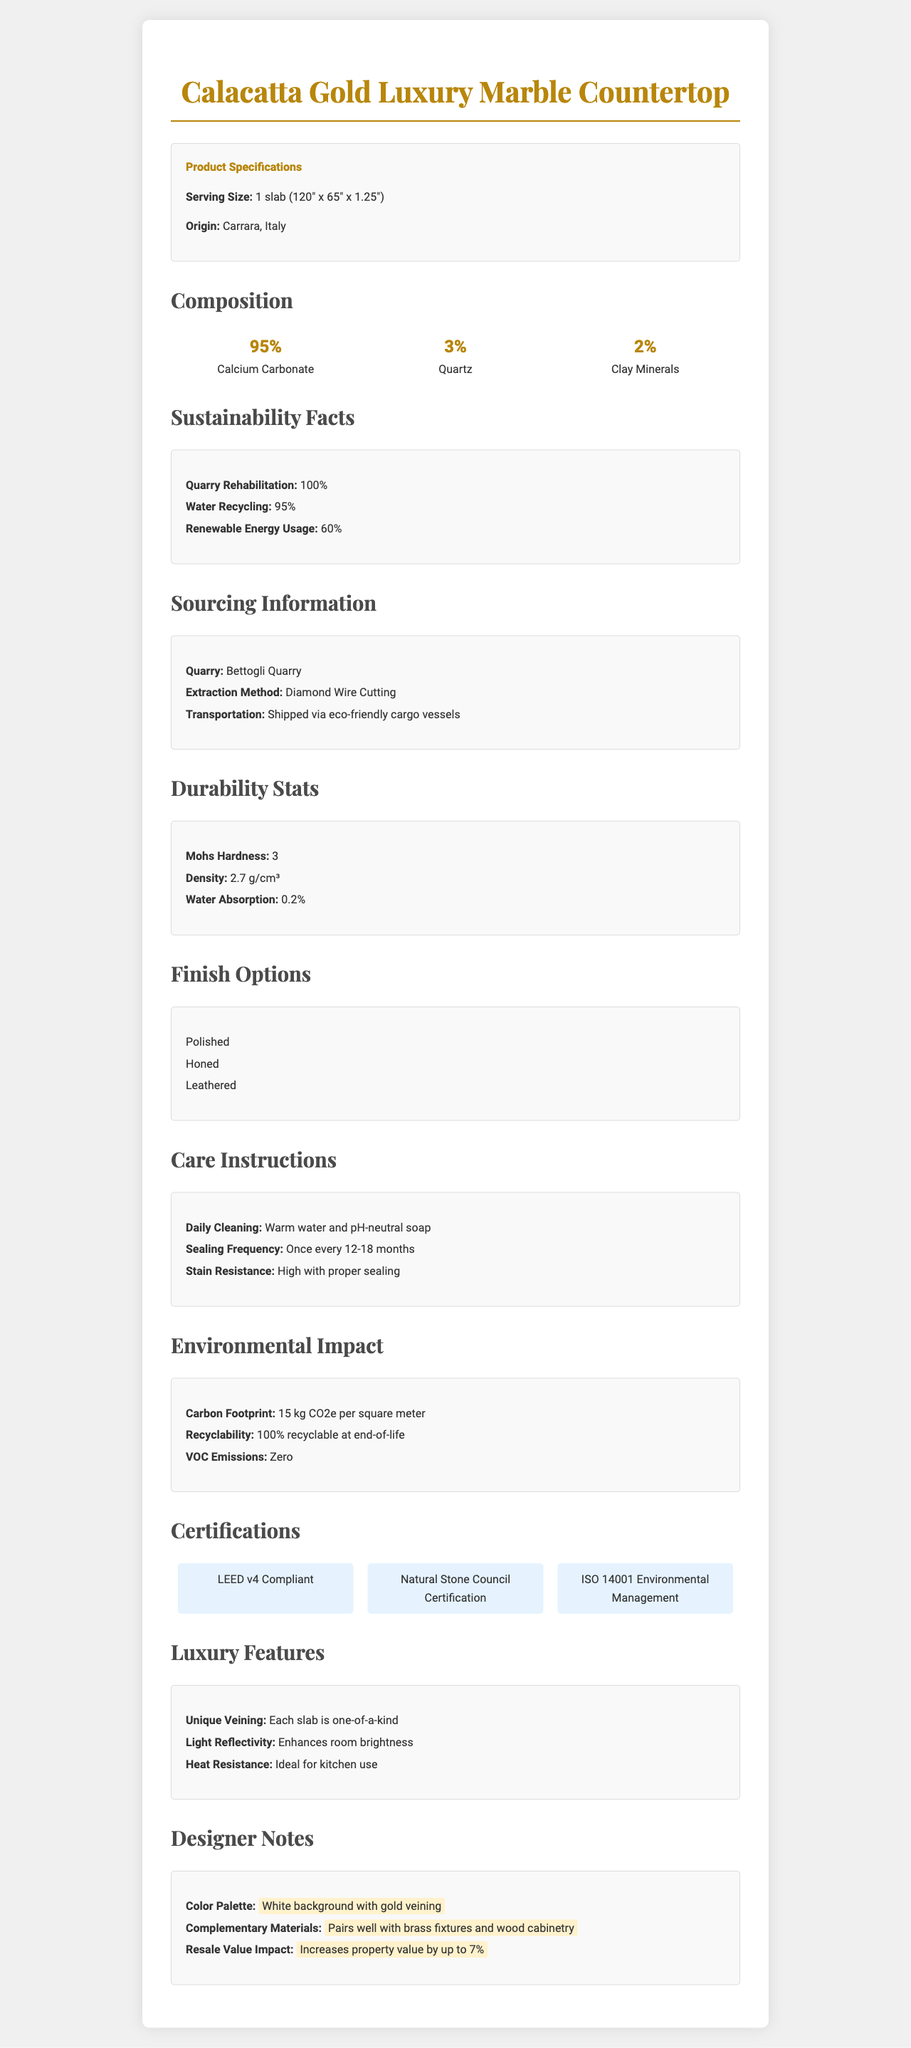what is the serving size of the marble countertop? The serving size mentioned in the Product Specifications section is "1 slab (120" x 65" x 1.25")".
Answer: 1 slab (120" x 65" x 1.25") where is the origin of the marble countertop? The origin is listed in the Product Specifications section under the heading "Origin".
Answer: Carrara, Italy what percentage of the marble countertop is composed of calcium carbonate? Under the Composition section, 95% is listed next to Calcium Carbonate.
Answer: 95% how frequently should the marble countertop be sealed? In the Care Instructions section, it specifies that sealing should occur "Once every 12-18 months".
Answer: Once every 12-18 months what is the water absorption rate of the marble countertop? The Durability Stats section lists the water absorption rate as "0.2%".
Answer: 0.2% which quarry is this marble sourced from? The Sourcing Information section states that the marble is sourced from the "Bettogli Quarry".
Answer: Bettogli Quarry what is the primary extraction method for this marble? A. Jackhammering B. Diamond Wire Cutting C. Explosive Blasting D. Hand Tools The Sourcing Information section lists the extraction method as "Diamond Wire Cutting".
Answer: B. Diamond Wire Cutting how many finish options are available for the marble countertop? A. 2 B. 3 C. 4 D. 5 The Finish Options section lists "Polished", "Honed", and "Leathered", which sum up to three options.
Answer: B. 3 is the marble countertop recyclable? In the Environmental Impact section, it is stated that the marble is "100% recyclable at end-of-life".
Answer: Yes does the marble countertop contribute to increasing property value? The Designer Notes section mentions that this marble countertop "Increases property value by up to 7%".
Answer: Yes what is the light reflectivity feature of the marble countertop? The Luxury Features section notes that the countertop "Enhances room brightness".
Answer: Enhances room brightness what certification ensures the marble's compliance with environmental management standards? The Certifications section lists "ISO 14001 Environmental Management" as one of the certifications.
Answer: ISO 14001 Environmental Management what is the daily cleaning recommendation for the marble countertop? Under Care Instructions, it is recommended to use "Warm water and pH-neutral soap" for daily cleaning.
Answer: Warm water and pH-neutral soap what is the carbon footprint of the marble countertop per square meter? The Environmental Impact section lists the carbon footprint as "15 kg CO2e per square meter".
Answer: 15 kg CO2e per square meter provide a summary of the document's main idea. This document extensively covers all aspects of the Calacatta Gold Luxury Marble Countertop, including its sourcing origin, composition percentages, sustainability practices, detailed care instructions, and notable features making it a luxury product, aimed at aiding property developers in making informed decisions about their interior design projects.
Answer: The document details the specifications, composition, sustainability, sourcing, durability, finish options, care instructions, environmental impact, certifications, luxury features, and designer notes about the Calacatta Gold Luxury Marble Countertop. how many certifications does the marble countertop have? The Certifications section lists "LEED v4 Compliant", "Natural Stone Council Certification", and "ISO 14001 Environmental Management", totaling three certifications.
Answer: Three what percentage of water recycling is achieved in quarry operations? The Sustainability Facts section states "Water Recycling: 95%".
Answer: 95% describe the color palette and complementary materials for this marble countertop. The Designer Notes section describes the color palette as "White background with gold veining" and mentions that it "pairs well with brass fixtures and wood cabinetry".
Answer: White background with gold veining; pairs well with brass fixtures and wood cabinetry what is the percent composition of clay minerals in the marble countertop? In the Composition section, 2% is listed next to Clay Minerals.
Answer: 2% when was the Bettogli Quarry founded? The document does not provide any details about the founding date of the Bettogli Quarry.
Answer: Not enough information 